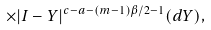<formula> <loc_0><loc_0><loc_500><loc_500>\times | I - Y | ^ { c - a - ( m - 1 ) \beta / 2 - 1 } ( d Y ) ,</formula> 